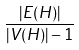Convert formula to latex. <formula><loc_0><loc_0><loc_500><loc_500>\frac { | E ( H ) | } { | V ( H ) | - 1 }</formula> 